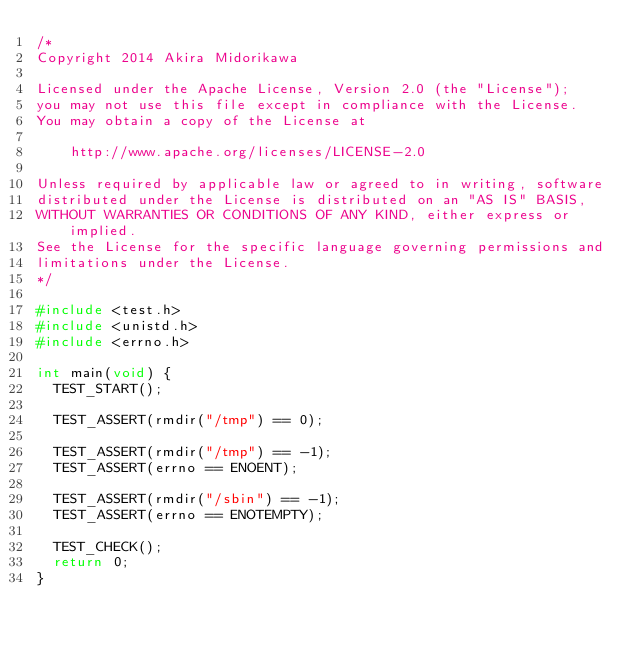<code> <loc_0><loc_0><loc_500><loc_500><_C_>/*
Copyright 2014 Akira Midorikawa

Licensed under the Apache License, Version 2.0 (the "License");
you may not use this file except in compliance with the License.
You may obtain a copy of the License at

    http://www.apache.org/licenses/LICENSE-2.0

Unless required by applicable law or agreed to in writing, software
distributed under the License is distributed on an "AS IS" BASIS,
WITHOUT WARRANTIES OR CONDITIONS OF ANY KIND, either express or implied.
See the License for the specific language governing permissions and
limitations under the License.
*/

#include <test.h>
#include <unistd.h>
#include <errno.h>

int main(void) {
  TEST_START();

  TEST_ASSERT(rmdir("/tmp") == 0);

  TEST_ASSERT(rmdir("/tmp") == -1);
  TEST_ASSERT(errno == ENOENT);

  TEST_ASSERT(rmdir("/sbin") == -1);
  TEST_ASSERT(errno == ENOTEMPTY);

  TEST_CHECK();
  return 0;
}
</code> 